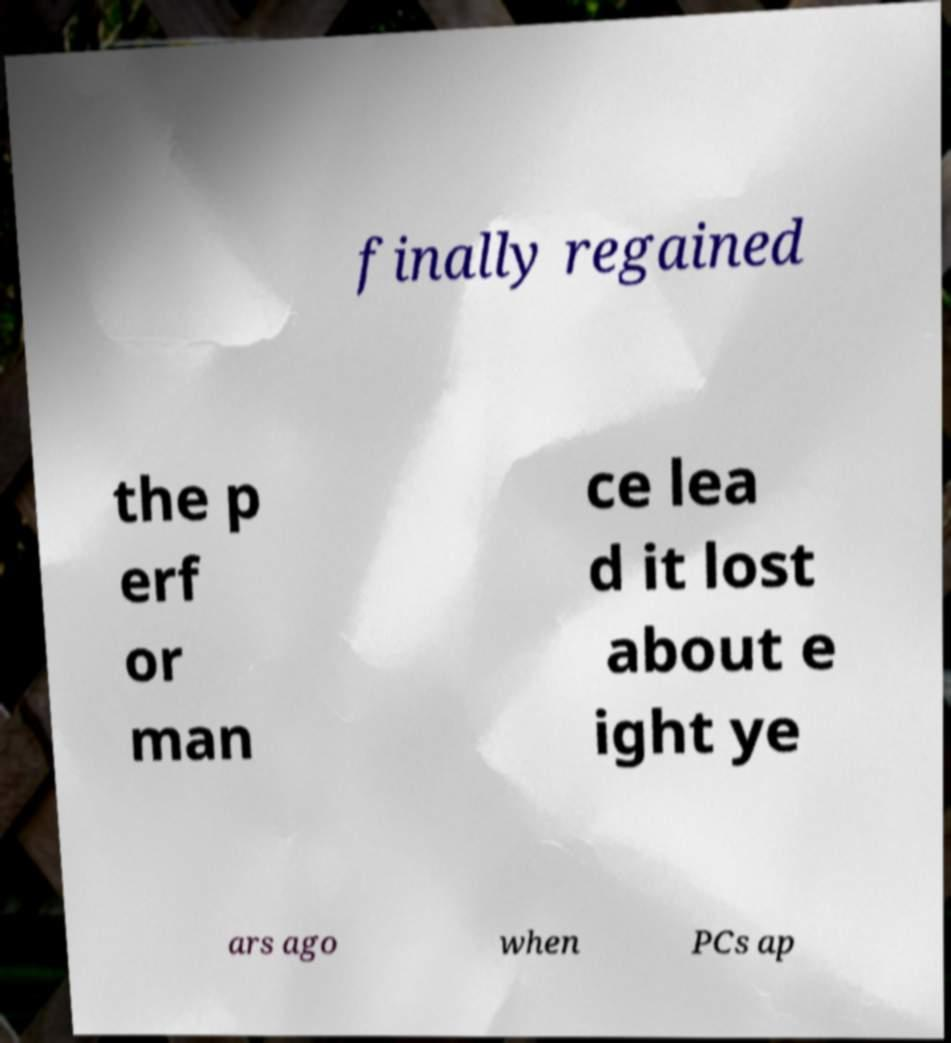What messages or text are displayed in this image? I need them in a readable, typed format. finally regained the p erf or man ce lea d it lost about e ight ye ars ago when PCs ap 